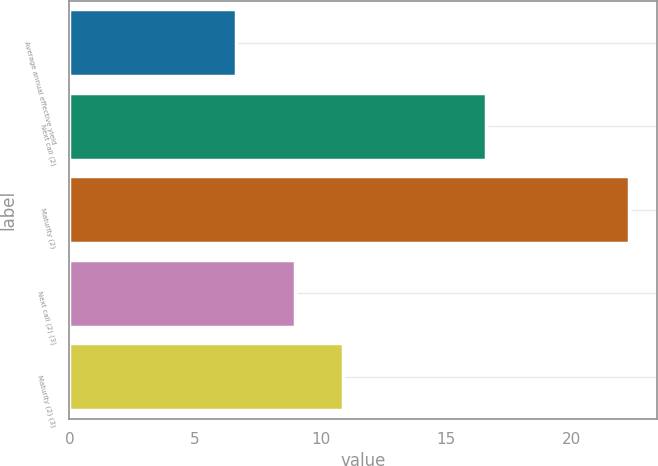Convert chart. <chart><loc_0><loc_0><loc_500><loc_500><bar_chart><fcel>Average annual effective yield<fcel>Next call (2)<fcel>Maturity (2)<fcel>Next call (2) (3)<fcel>Maturity (2) (3)<nl><fcel>6.63<fcel>16.6<fcel>22.3<fcel>9<fcel>10.9<nl></chart> 